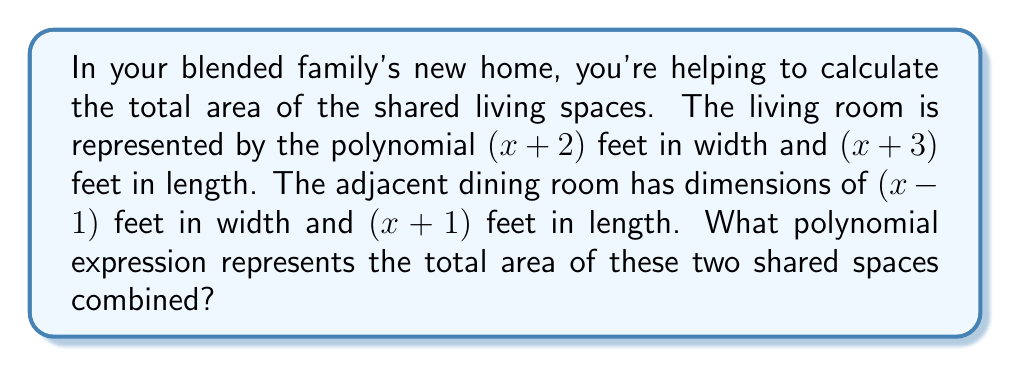Solve this math problem. Let's approach this step-by-step:

1. Calculate the area of the living room:
   $$(x + 2)(x + 3)$$
   Expanding this:
   $$x^2 + 3x + 2x + 6 = x^2 + 5x + 6$$

2. Calculate the area of the dining room:
   $$(x - 1)(x + 1)$$
   Expanding this:
   $$x^2 + x - x - 1 = x^2 - 1$$

3. To find the total area, we add these two polynomials:
   $$(x^2 + 5x + 6) + (x^2 - 1)$$

4. Combining like terms:
   $$2x^2 + 5x + 5$$

This polynomial represents the total area of both shared spaces in square feet.
Answer: $2x^2 + 5x + 5$ 